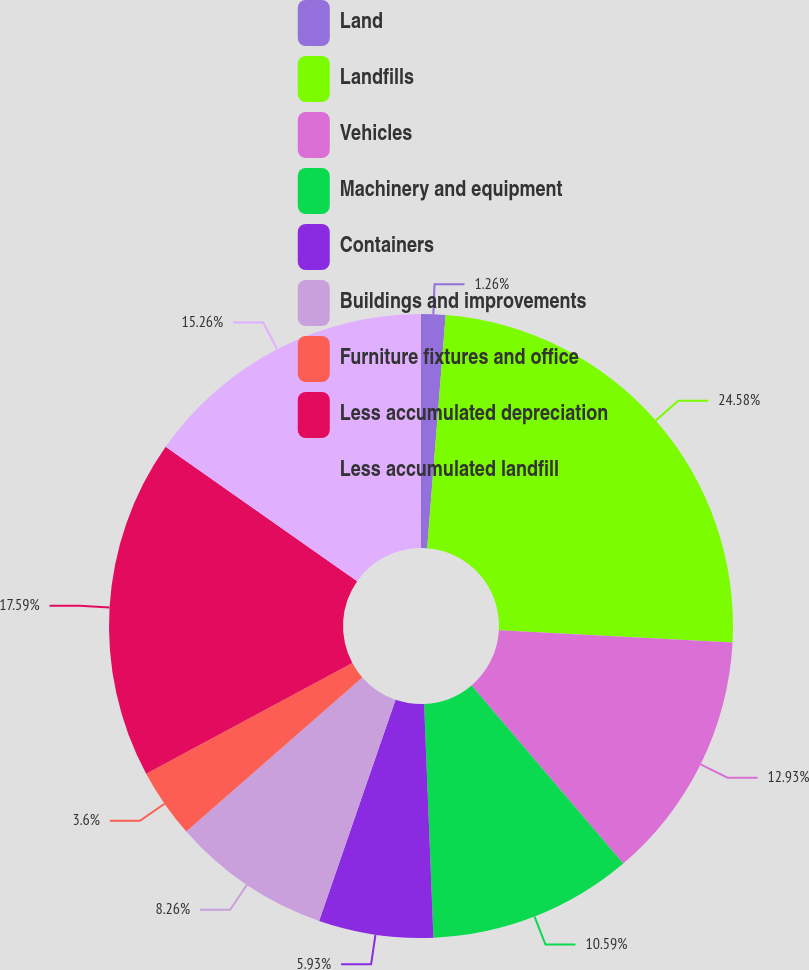Convert chart. <chart><loc_0><loc_0><loc_500><loc_500><pie_chart><fcel>Land<fcel>Landfills<fcel>Vehicles<fcel>Machinery and equipment<fcel>Containers<fcel>Buildings and improvements<fcel>Furniture fixtures and office<fcel>Less accumulated depreciation<fcel>Less accumulated landfill<nl><fcel>1.26%<fcel>24.59%<fcel>12.93%<fcel>10.59%<fcel>5.93%<fcel>8.26%<fcel>3.6%<fcel>17.59%<fcel>15.26%<nl></chart> 